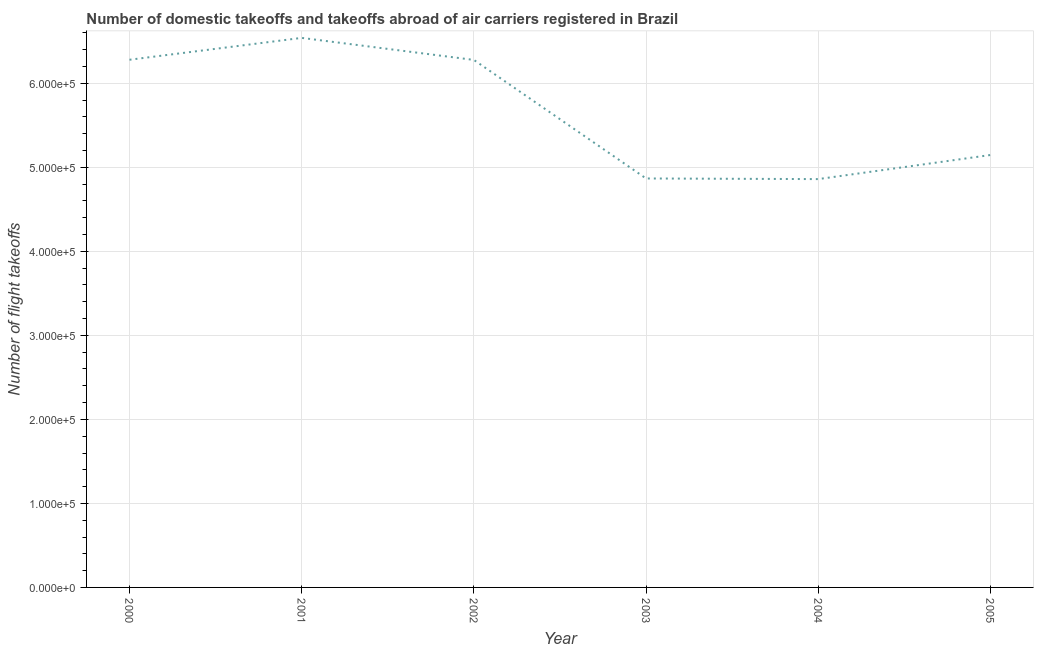What is the number of flight takeoffs in 2001?
Offer a very short reply. 6.54e+05. Across all years, what is the maximum number of flight takeoffs?
Give a very brief answer. 6.54e+05. Across all years, what is the minimum number of flight takeoffs?
Provide a short and direct response. 4.86e+05. In which year was the number of flight takeoffs minimum?
Give a very brief answer. 2004. What is the sum of the number of flight takeoffs?
Give a very brief answer. 3.40e+06. What is the difference between the number of flight takeoffs in 2002 and 2003?
Provide a succinct answer. 1.41e+05. What is the average number of flight takeoffs per year?
Your answer should be very brief. 5.66e+05. What is the median number of flight takeoffs?
Ensure brevity in your answer.  5.71e+05. Do a majority of the years between 2001 and 2000 (inclusive) have number of flight takeoffs greater than 260000 ?
Provide a short and direct response. No. What is the ratio of the number of flight takeoffs in 2000 to that in 2005?
Provide a succinct answer. 1.22. Is the number of flight takeoffs in 2001 less than that in 2005?
Your response must be concise. No. Is the difference between the number of flight takeoffs in 2001 and 2002 greater than the difference between any two years?
Your response must be concise. No. What is the difference between the highest and the second highest number of flight takeoffs?
Offer a terse response. 2.60e+04. Is the sum of the number of flight takeoffs in 2000 and 2004 greater than the maximum number of flight takeoffs across all years?
Keep it short and to the point. Yes. What is the difference between the highest and the lowest number of flight takeoffs?
Keep it short and to the point. 1.68e+05. In how many years, is the number of flight takeoffs greater than the average number of flight takeoffs taken over all years?
Your answer should be compact. 3. What is the difference between two consecutive major ticks on the Y-axis?
Offer a terse response. 1.00e+05. Does the graph contain grids?
Offer a terse response. Yes. What is the title of the graph?
Ensure brevity in your answer.  Number of domestic takeoffs and takeoffs abroad of air carriers registered in Brazil. What is the label or title of the X-axis?
Your response must be concise. Year. What is the label or title of the Y-axis?
Give a very brief answer. Number of flight takeoffs. What is the Number of flight takeoffs in 2000?
Ensure brevity in your answer.  6.28e+05. What is the Number of flight takeoffs of 2001?
Your answer should be compact. 6.54e+05. What is the Number of flight takeoffs in 2002?
Give a very brief answer. 6.28e+05. What is the Number of flight takeoffs of 2003?
Give a very brief answer. 4.87e+05. What is the Number of flight takeoffs in 2004?
Offer a very short reply. 4.86e+05. What is the Number of flight takeoffs of 2005?
Give a very brief answer. 5.15e+05. What is the difference between the Number of flight takeoffs in 2000 and 2001?
Make the answer very short. -2.60e+04. What is the difference between the Number of flight takeoffs in 2000 and 2002?
Give a very brief answer. 203. What is the difference between the Number of flight takeoffs in 2000 and 2003?
Your answer should be compact. 1.41e+05. What is the difference between the Number of flight takeoffs in 2000 and 2004?
Provide a short and direct response. 1.42e+05. What is the difference between the Number of flight takeoffs in 2000 and 2005?
Your response must be concise. 1.13e+05. What is the difference between the Number of flight takeoffs in 2001 and 2002?
Make the answer very short. 2.62e+04. What is the difference between the Number of flight takeoffs in 2001 and 2003?
Provide a succinct answer. 1.67e+05. What is the difference between the Number of flight takeoffs in 2001 and 2004?
Offer a terse response. 1.68e+05. What is the difference between the Number of flight takeoffs in 2001 and 2005?
Your answer should be compact. 1.39e+05. What is the difference between the Number of flight takeoffs in 2002 and 2003?
Provide a short and direct response. 1.41e+05. What is the difference between the Number of flight takeoffs in 2002 and 2004?
Your answer should be compact. 1.42e+05. What is the difference between the Number of flight takeoffs in 2002 and 2005?
Give a very brief answer. 1.13e+05. What is the difference between the Number of flight takeoffs in 2003 and 2004?
Make the answer very short. 752. What is the difference between the Number of flight takeoffs in 2003 and 2005?
Offer a very short reply. -2.79e+04. What is the difference between the Number of flight takeoffs in 2004 and 2005?
Provide a short and direct response. -2.87e+04. What is the ratio of the Number of flight takeoffs in 2000 to that in 2002?
Ensure brevity in your answer.  1. What is the ratio of the Number of flight takeoffs in 2000 to that in 2003?
Offer a terse response. 1.29. What is the ratio of the Number of flight takeoffs in 2000 to that in 2004?
Keep it short and to the point. 1.29. What is the ratio of the Number of flight takeoffs in 2000 to that in 2005?
Ensure brevity in your answer.  1.22. What is the ratio of the Number of flight takeoffs in 2001 to that in 2002?
Provide a short and direct response. 1.04. What is the ratio of the Number of flight takeoffs in 2001 to that in 2003?
Offer a terse response. 1.34. What is the ratio of the Number of flight takeoffs in 2001 to that in 2004?
Keep it short and to the point. 1.35. What is the ratio of the Number of flight takeoffs in 2001 to that in 2005?
Give a very brief answer. 1.27. What is the ratio of the Number of flight takeoffs in 2002 to that in 2003?
Provide a short and direct response. 1.29. What is the ratio of the Number of flight takeoffs in 2002 to that in 2004?
Offer a terse response. 1.29. What is the ratio of the Number of flight takeoffs in 2002 to that in 2005?
Provide a succinct answer. 1.22. What is the ratio of the Number of flight takeoffs in 2003 to that in 2005?
Provide a short and direct response. 0.95. What is the ratio of the Number of flight takeoffs in 2004 to that in 2005?
Make the answer very short. 0.94. 